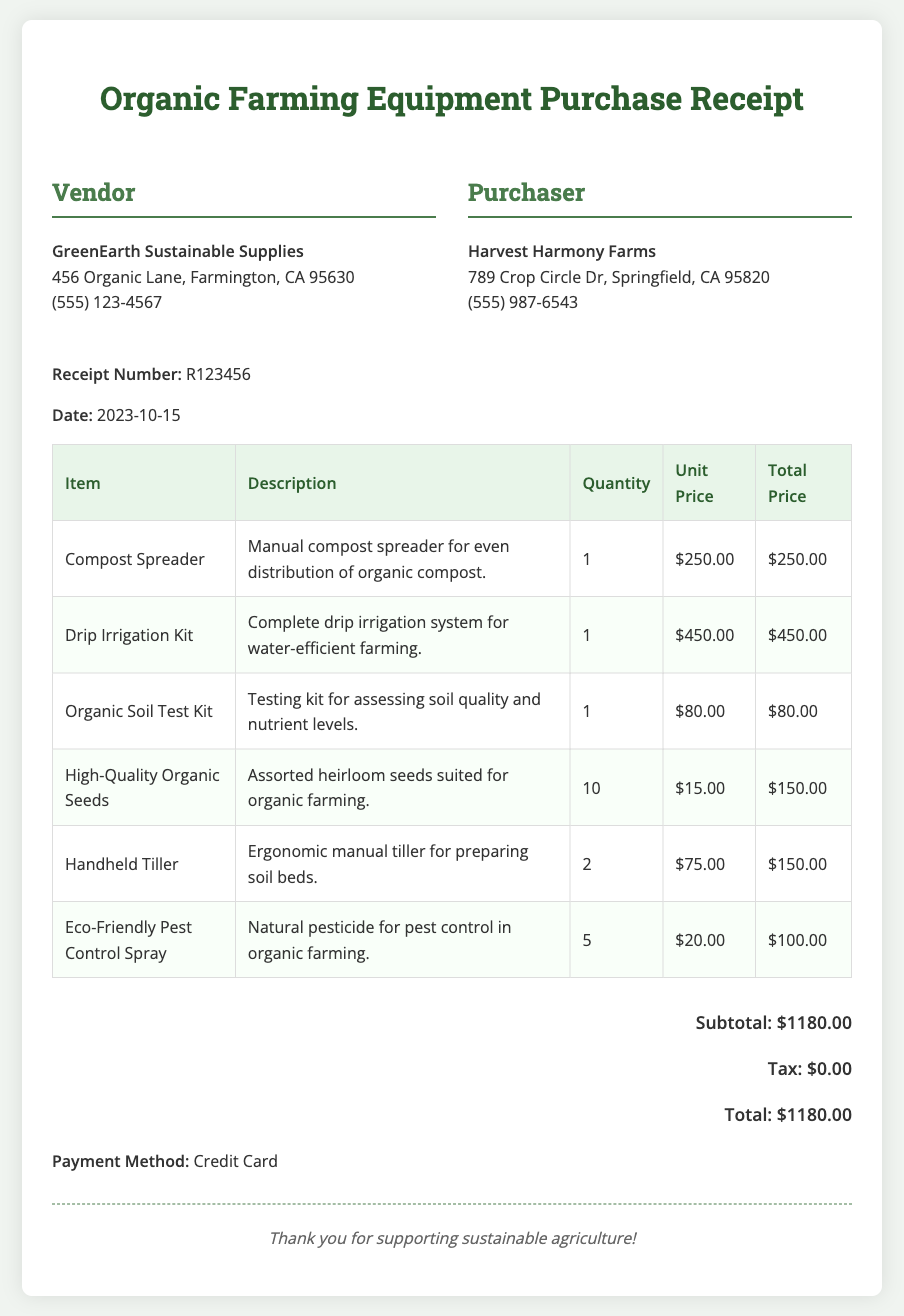What is the vendor's name? The vendor's name is presented in the vendor section of the document, indicating who sold the equipment.
Answer: GreenEarth Sustainable Supplies What is the purchase date? The purchase date is displayed prominently near the receipt number, indicating when the transaction took place.
Answer: 2023-10-15 How much did the Compost Spreader cost? The cost of the Compost Spreader can be found in the itemized list, indicating the price for each piece of equipment.
Answer: $250.00 What is the total price of the organic seeds? The total price for the organic seeds is calculated based on the quantity purchased and the unit price, found in the table.
Answer: $150.00 What payment method was used? The payment method is explicitly stated toward the end of the document, indicating how the transaction was completed.
Answer: Credit Card How many items were purchased in total? The total number of items can be counted in the itemized list, which shows the quantity alongside each item description.
Answer: 19 What is the subtotal of the purchase? The subtotal is calculated as the sum of all item totals, which is clearly labeled in the totals section.
Answer: $1180.00 Which item had the highest cost? The item with the highest cost can be identified by analyzing the unit prices in the itemized list.
Answer: Drip Irrigation Kit Is there tax applied to this transaction? The tax section of the totals shows whether any tax was added to the subtotal of the purchase.
Answer: $0.00 